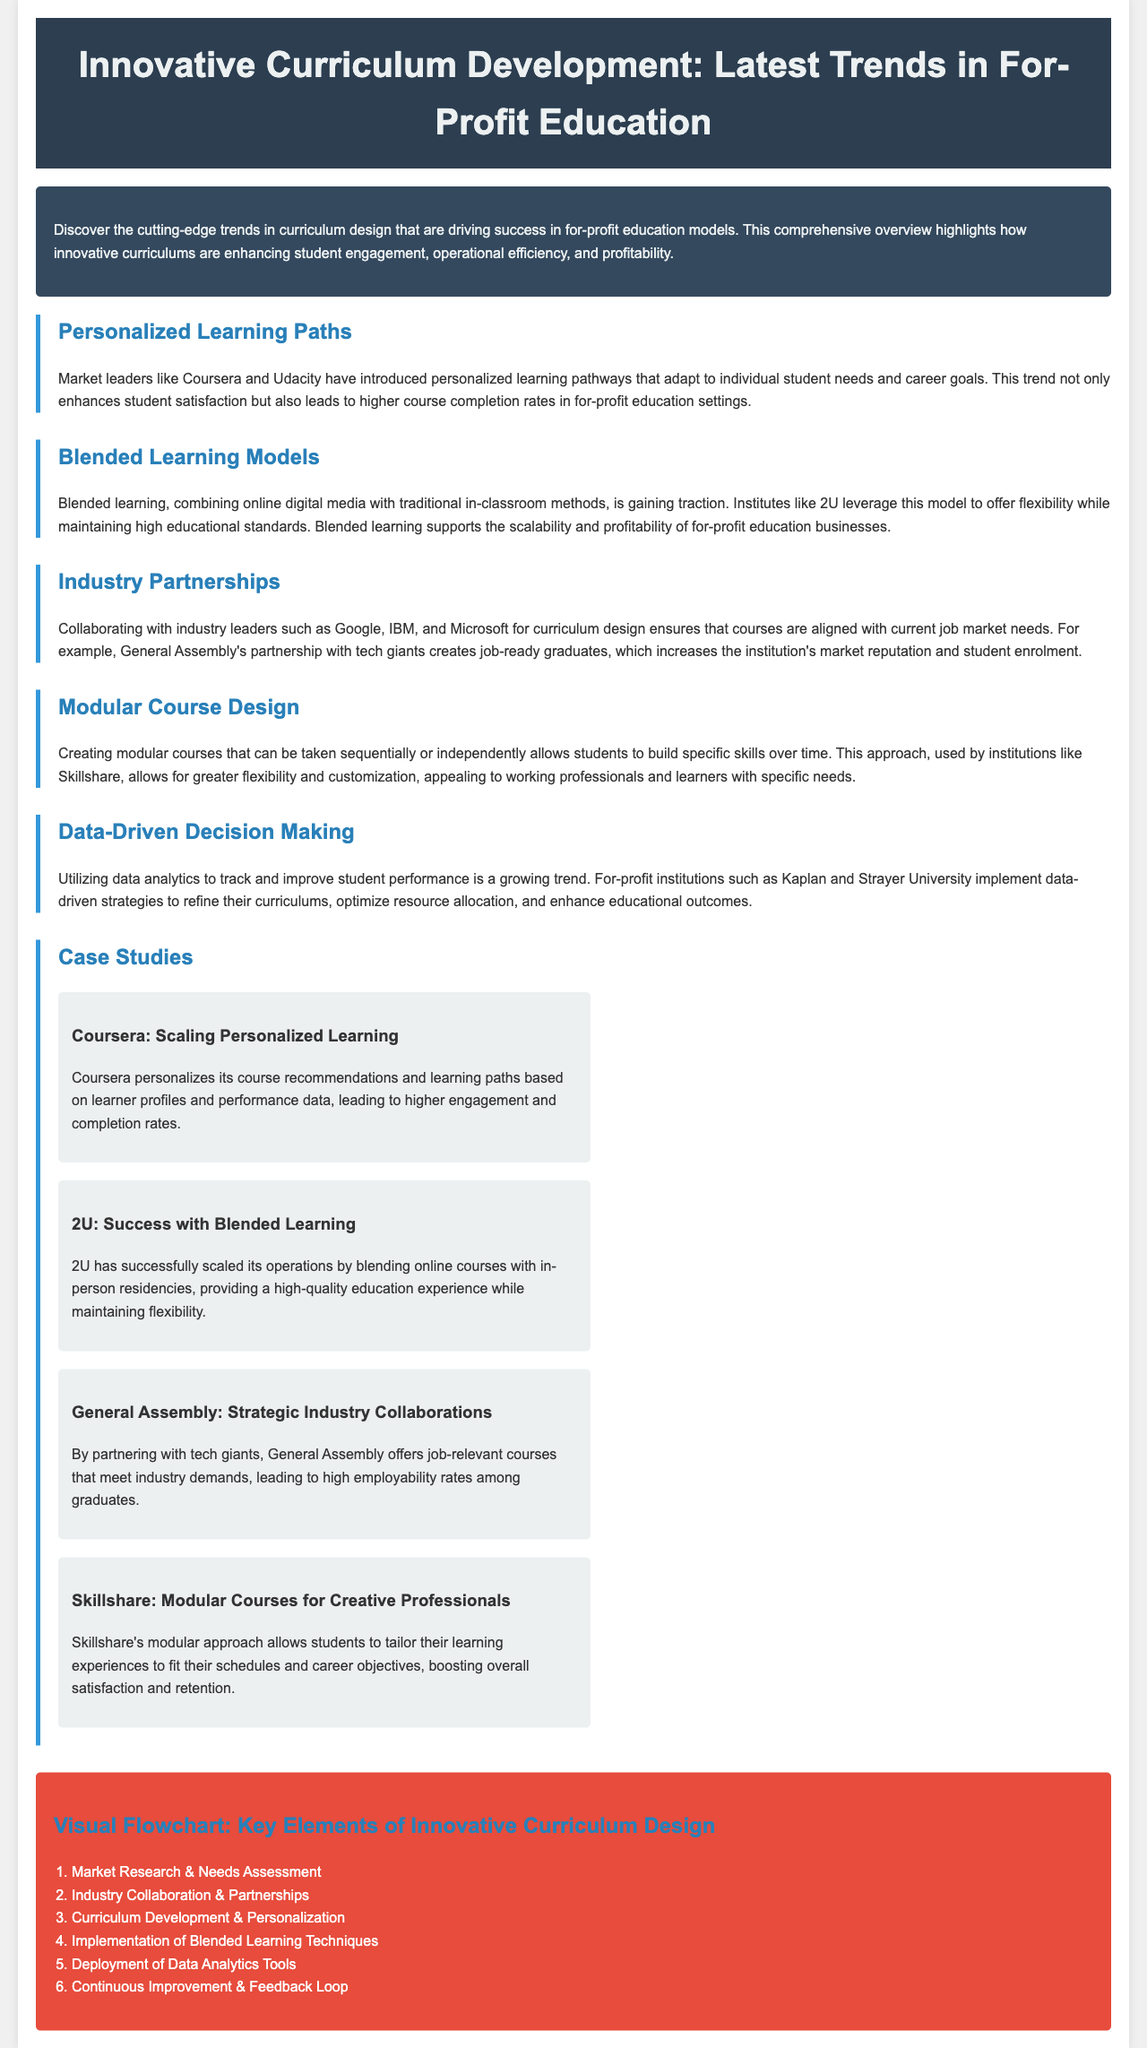What is the main focus of the document? The document discusses the latest trends in curriculum design tailored for for-profit education models.
Answer: Latest trends in curriculum design Which company is known for scaling personalized learning paths? The document mentions Coursera as a leader in personalized learning pathways.
Answer: Coursera What learning model is gaining traction according to the document? The document states that blended learning, combining online and traditional methods, is becoming more popular.
Answer: Blended learning Which institution collaborates with industry leaders like Google and IBM? General Assembly is noted for collaborating with industry leaders for curriculum design.
Answer: General Assembly How does Skillshare allow students to achieve greater flexibility? The document mentions that Skillshare provides modular courses that can be taken independently.
Answer: Modular courses What visual element summarizes key components of innovative curriculum design? A visual flowchart is included to illustrate the key elements in curriculum design.
Answer: Visual flowchart How many case studies are presented in the document? The document includes four case studies highlighting various institutions' approaches.
Answer: Four What innovative strategy is used by Kaplan and Strayer University? Both institutions utilize data analytics for tracking and improving student performance.
Answer: Data-driven decision making What is a notable outcome of General Assembly's partnerships? The partnerships lead to high employability rates among graduates.
Answer: High employability rates 